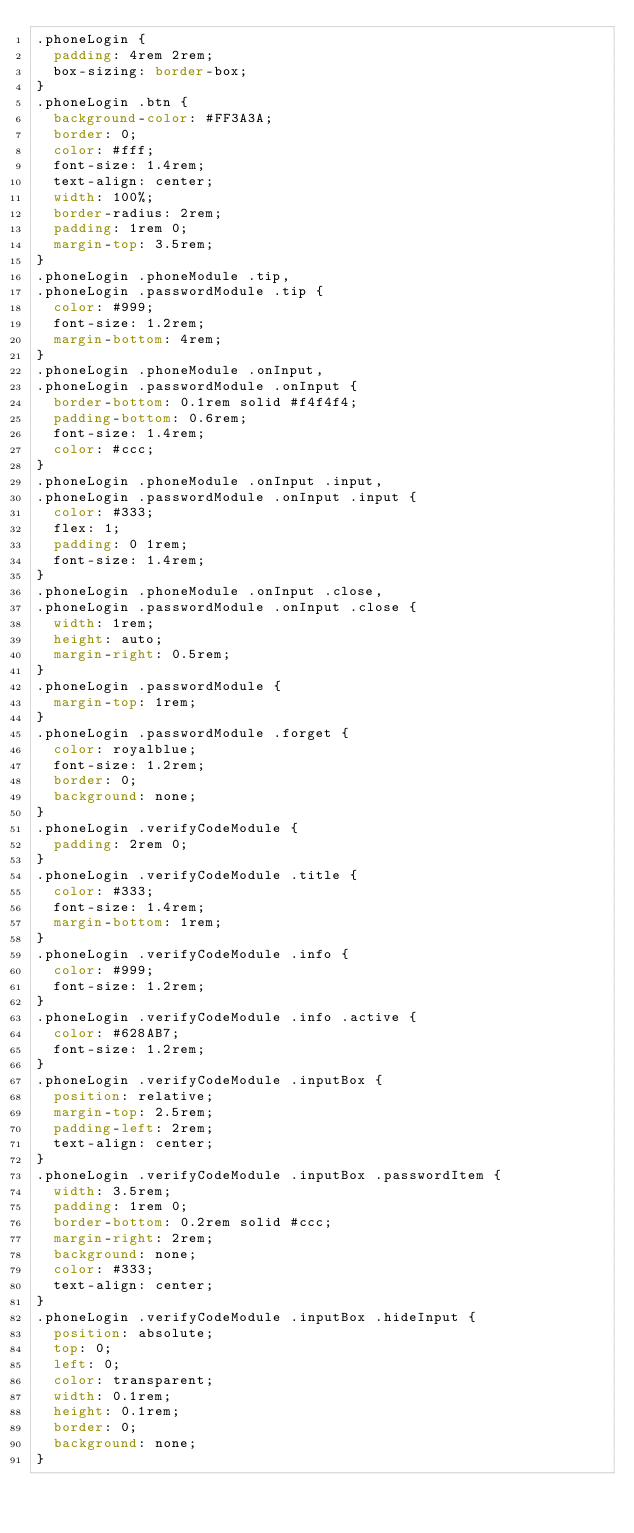Convert code to text. <code><loc_0><loc_0><loc_500><loc_500><_CSS_>.phoneLogin {
  padding: 4rem 2rem;
  box-sizing: border-box;
}
.phoneLogin .btn {
  background-color: #FF3A3A;
  border: 0;
  color: #fff;
  font-size: 1.4rem;
  text-align: center;
  width: 100%;
  border-radius: 2rem;
  padding: 1rem 0;
  margin-top: 3.5rem;
}
.phoneLogin .phoneModule .tip,
.phoneLogin .passwordModule .tip {
  color: #999;
  font-size: 1.2rem;
  margin-bottom: 4rem;
}
.phoneLogin .phoneModule .onInput,
.phoneLogin .passwordModule .onInput {
  border-bottom: 0.1rem solid #f4f4f4;
  padding-bottom: 0.6rem;
  font-size: 1.4rem;
  color: #ccc;
}
.phoneLogin .phoneModule .onInput .input,
.phoneLogin .passwordModule .onInput .input {
  color: #333;
  flex: 1;
  padding: 0 1rem;
  font-size: 1.4rem;
}
.phoneLogin .phoneModule .onInput .close,
.phoneLogin .passwordModule .onInput .close {
  width: 1rem;
  height: auto;
  margin-right: 0.5rem;
}
.phoneLogin .passwordModule {
  margin-top: 1rem;
}
.phoneLogin .passwordModule .forget {
  color: royalblue;
  font-size: 1.2rem;
  border: 0;
  background: none;
}
.phoneLogin .verifyCodeModule {
  padding: 2rem 0;
}
.phoneLogin .verifyCodeModule .title {
  color: #333;
  font-size: 1.4rem;
  margin-bottom: 1rem;
}
.phoneLogin .verifyCodeModule .info {
  color: #999;
  font-size: 1.2rem;
}
.phoneLogin .verifyCodeModule .info .active {
  color: #628AB7;
  font-size: 1.2rem;
}
.phoneLogin .verifyCodeModule .inputBox {
  position: relative;
  margin-top: 2.5rem;
  padding-left: 2rem;
  text-align: center;
}
.phoneLogin .verifyCodeModule .inputBox .passwordItem {
  width: 3.5rem;
  padding: 1rem 0;
  border-bottom: 0.2rem solid #ccc;
  margin-right: 2rem;
  background: none;
  color: #333;
  text-align: center;
}
.phoneLogin .verifyCodeModule .inputBox .hideInput {
  position: absolute;
  top: 0;
  left: 0;
  color: transparent;
  width: 0.1rem;
  height: 0.1rem;
  border: 0;
  background: none;
}
</code> 